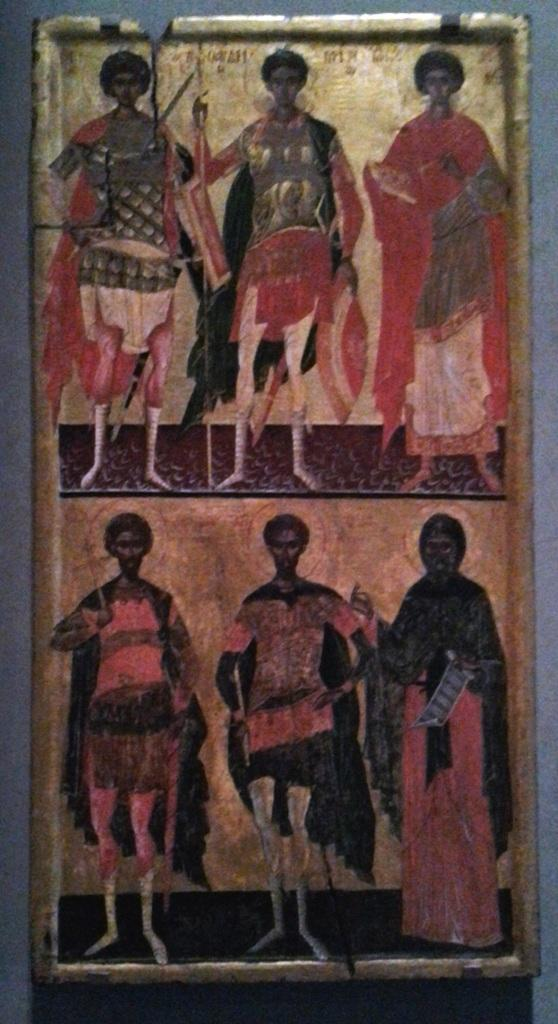What is the main subject in the foreground of the image? There is a frame in the foreground of the image. What type of jewel is displayed in the frame in the image? There is no jewel displayed in the frame in the image; only the frame itself is visible. 